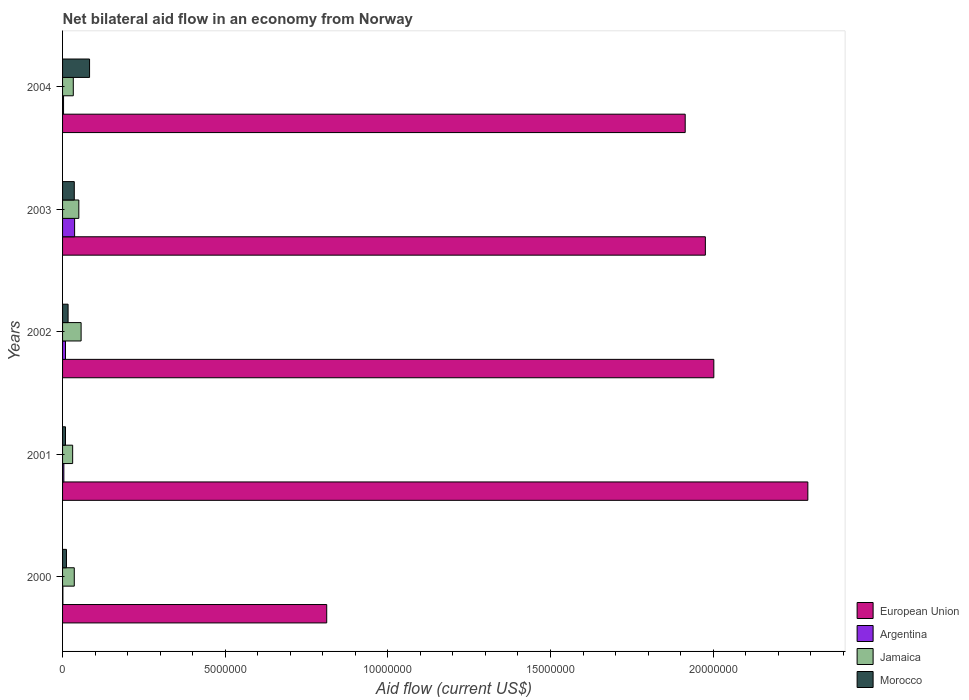How many different coloured bars are there?
Provide a succinct answer. 4. How many bars are there on the 4th tick from the top?
Provide a short and direct response. 4. What is the label of the 2nd group of bars from the top?
Provide a succinct answer. 2003. In how many cases, is the number of bars for a given year not equal to the number of legend labels?
Offer a very short reply. 0. Across all years, what is the maximum net bilateral aid flow in Argentina?
Offer a very short reply. 3.70e+05. Across all years, what is the minimum net bilateral aid flow in Jamaica?
Your response must be concise. 3.10e+05. In which year was the net bilateral aid flow in Jamaica minimum?
Offer a terse response. 2001. What is the total net bilateral aid flow in Jamaica in the graph?
Provide a short and direct response. 2.07e+06. What is the difference between the net bilateral aid flow in Morocco in 2003 and that in 2004?
Offer a terse response. -4.70e+05. What is the difference between the net bilateral aid flow in European Union in 2004 and the net bilateral aid flow in Argentina in 2001?
Offer a very short reply. 1.91e+07. What is the average net bilateral aid flow in Morocco per year?
Provide a short and direct response. 3.14e+05. In the year 2002, what is the difference between the net bilateral aid flow in Morocco and net bilateral aid flow in Jamaica?
Your answer should be compact. -4.00e+05. In how many years, is the net bilateral aid flow in European Union greater than 8000000 US$?
Ensure brevity in your answer.  5. What is the ratio of the net bilateral aid flow in Morocco in 2000 to that in 2001?
Your answer should be very brief. 1.33. Is the net bilateral aid flow in Jamaica in 2000 less than that in 2003?
Your response must be concise. Yes. Is the difference between the net bilateral aid flow in Morocco in 2003 and 2004 greater than the difference between the net bilateral aid flow in Jamaica in 2003 and 2004?
Your answer should be very brief. No. What is the difference between the highest and the second highest net bilateral aid flow in Morocco?
Provide a short and direct response. 4.70e+05. What is the difference between the highest and the lowest net bilateral aid flow in European Union?
Your response must be concise. 1.48e+07. Is it the case that in every year, the sum of the net bilateral aid flow in Argentina and net bilateral aid flow in European Union is greater than the sum of net bilateral aid flow in Jamaica and net bilateral aid flow in Morocco?
Keep it short and to the point. Yes. What does the 4th bar from the top in 2001 represents?
Your response must be concise. European Union. What does the 1st bar from the bottom in 2001 represents?
Provide a succinct answer. European Union. Is it the case that in every year, the sum of the net bilateral aid flow in European Union and net bilateral aid flow in Jamaica is greater than the net bilateral aid flow in Morocco?
Offer a very short reply. Yes. Are all the bars in the graph horizontal?
Your response must be concise. Yes. What is the difference between two consecutive major ticks on the X-axis?
Your answer should be very brief. 5.00e+06. Are the values on the major ticks of X-axis written in scientific E-notation?
Offer a very short reply. No. Does the graph contain grids?
Offer a terse response. No. How many legend labels are there?
Your answer should be very brief. 4. What is the title of the graph?
Ensure brevity in your answer.  Net bilateral aid flow in an economy from Norway. Does "Hong Kong" appear as one of the legend labels in the graph?
Offer a very short reply. No. What is the label or title of the X-axis?
Ensure brevity in your answer.  Aid flow (current US$). What is the label or title of the Y-axis?
Your response must be concise. Years. What is the Aid flow (current US$) in European Union in 2000?
Offer a terse response. 8.12e+06. What is the Aid flow (current US$) of Argentina in 2000?
Keep it short and to the point. 10000. What is the Aid flow (current US$) in Jamaica in 2000?
Offer a terse response. 3.60e+05. What is the Aid flow (current US$) of European Union in 2001?
Offer a very short reply. 2.29e+07. What is the Aid flow (current US$) in Argentina in 2001?
Provide a short and direct response. 4.00e+04. What is the Aid flow (current US$) in Morocco in 2001?
Your answer should be compact. 9.00e+04. What is the Aid flow (current US$) of European Union in 2002?
Your answer should be very brief. 2.00e+07. What is the Aid flow (current US$) of Argentina in 2002?
Offer a terse response. 9.00e+04. What is the Aid flow (current US$) of Jamaica in 2002?
Offer a very short reply. 5.70e+05. What is the Aid flow (current US$) in European Union in 2003?
Ensure brevity in your answer.  1.98e+07. What is the Aid flow (current US$) of Jamaica in 2003?
Keep it short and to the point. 5.00e+05. What is the Aid flow (current US$) in Morocco in 2003?
Your answer should be very brief. 3.60e+05. What is the Aid flow (current US$) in European Union in 2004?
Your answer should be very brief. 1.91e+07. What is the Aid flow (current US$) of Jamaica in 2004?
Provide a succinct answer. 3.30e+05. What is the Aid flow (current US$) in Morocco in 2004?
Provide a succinct answer. 8.30e+05. Across all years, what is the maximum Aid flow (current US$) in European Union?
Your answer should be compact. 2.29e+07. Across all years, what is the maximum Aid flow (current US$) in Argentina?
Make the answer very short. 3.70e+05. Across all years, what is the maximum Aid flow (current US$) of Jamaica?
Keep it short and to the point. 5.70e+05. Across all years, what is the maximum Aid flow (current US$) in Morocco?
Ensure brevity in your answer.  8.30e+05. Across all years, what is the minimum Aid flow (current US$) in European Union?
Your answer should be compact. 8.12e+06. Across all years, what is the minimum Aid flow (current US$) in Jamaica?
Your response must be concise. 3.10e+05. What is the total Aid flow (current US$) of European Union in the graph?
Your response must be concise. 9.00e+07. What is the total Aid flow (current US$) in Argentina in the graph?
Your response must be concise. 5.40e+05. What is the total Aid flow (current US$) of Jamaica in the graph?
Your answer should be very brief. 2.07e+06. What is the total Aid flow (current US$) of Morocco in the graph?
Give a very brief answer. 1.57e+06. What is the difference between the Aid flow (current US$) in European Union in 2000 and that in 2001?
Offer a terse response. -1.48e+07. What is the difference between the Aid flow (current US$) of Argentina in 2000 and that in 2001?
Offer a terse response. -3.00e+04. What is the difference between the Aid flow (current US$) of Jamaica in 2000 and that in 2001?
Offer a very short reply. 5.00e+04. What is the difference between the Aid flow (current US$) of European Union in 2000 and that in 2002?
Keep it short and to the point. -1.19e+07. What is the difference between the Aid flow (current US$) in Argentina in 2000 and that in 2002?
Your answer should be compact. -8.00e+04. What is the difference between the Aid flow (current US$) in Jamaica in 2000 and that in 2002?
Offer a terse response. -2.10e+05. What is the difference between the Aid flow (current US$) in Morocco in 2000 and that in 2002?
Provide a succinct answer. -5.00e+04. What is the difference between the Aid flow (current US$) of European Union in 2000 and that in 2003?
Your answer should be compact. -1.16e+07. What is the difference between the Aid flow (current US$) of Argentina in 2000 and that in 2003?
Offer a terse response. -3.60e+05. What is the difference between the Aid flow (current US$) in Morocco in 2000 and that in 2003?
Your response must be concise. -2.40e+05. What is the difference between the Aid flow (current US$) of European Union in 2000 and that in 2004?
Make the answer very short. -1.10e+07. What is the difference between the Aid flow (current US$) in Argentina in 2000 and that in 2004?
Your answer should be very brief. -2.00e+04. What is the difference between the Aid flow (current US$) in Morocco in 2000 and that in 2004?
Your response must be concise. -7.10e+05. What is the difference between the Aid flow (current US$) of European Union in 2001 and that in 2002?
Your answer should be compact. 2.89e+06. What is the difference between the Aid flow (current US$) in Argentina in 2001 and that in 2002?
Ensure brevity in your answer.  -5.00e+04. What is the difference between the Aid flow (current US$) of Jamaica in 2001 and that in 2002?
Provide a succinct answer. -2.60e+05. What is the difference between the Aid flow (current US$) in European Union in 2001 and that in 2003?
Keep it short and to the point. 3.15e+06. What is the difference between the Aid flow (current US$) in Argentina in 2001 and that in 2003?
Your answer should be compact. -3.30e+05. What is the difference between the Aid flow (current US$) of European Union in 2001 and that in 2004?
Make the answer very short. 3.77e+06. What is the difference between the Aid flow (current US$) in Morocco in 2001 and that in 2004?
Give a very brief answer. -7.40e+05. What is the difference between the Aid flow (current US$) of European Union in 2002 and that in 2003?
Provide a short and direct response. 2.60e+05. What is the difference between the Aid flow (current US$) in Argentina in 2002 and that in 2003?
Provide a succinct answer. -2.80e+05. What is the difference between the Aid flow (current US$) of Morocco in 2002 and that in 2003?
Your answer should be compact. -1.90e+05. What is the difference between the Aid flow (current US$) in European Union in 2002 and that in 2004?
Offer a very short reply. 8.80e+05. What is the difference between the Aid flow (current US$) of Argentina in 2002 and that in 2004?
Ensure brevity in your answer.  6.00e+04. What is the difference between the Aid flow (current US$) of Jamaica in 2002 and that in 2004?
Keep it short and to the point. 2.40e+05. What is the difference between the Aid flow (current US$) of Morocco in 2002 and that in 2004?
Give a very brief answer. -6.60e+05. What is the difference between the Aid flow (current US$) of European Union in 2003 and that in 2004?
Give a very brief answer. 6.20e+05. What is the difference between the Aid flow (current US$) in Jamaica in 2003 and that in 2004?
Make the answer very short. 1.70e+05. What is the difference between the Aid flow (current US$) in Morocco in 2003 and that in 2004?
Your answer should be compact. -4.70e+05. What is the difference between the Aid flow (current US$) of European Union in 2000 and the Aid flow (current US$) of Argentina in 2001?
Provide a succinct answer. 8.08e+06. What is the difference between the Aid flow (current US$) in European Union in 2000 and the Aid flow (current US$) in Jamaica in 2001?
Your response must be concise. 7.81e+06. What is the difference between the Aid flow (current US$) of European Union in 2000 and the Aid flow (current US$) of Morocco in 2001?
Keep it short and to the point. 8.03e+06. What is the difference between the Aid flow (current US$) in Jamaica in 2000 and the Aid flow (current US$) in Morocco in 2001?
Your answer should be compact. 2.70e+05. What is the difference between the Aid flow (current US$) of European Union in 2000 and the Aid flow (current US$) of Argentina in 2002?
Offer a very short reply. 8.03e+06. What is the difference between the Aid flow (current US$) in European Union in 2000 and the Aid flow (current US$) in Jamaica in 2002?
Give a very brief answer. 7.55e+06. What is the difference between the Aid flow (current US$) of European Union in 2000 and the Aid flow (current US$) of Morocco in 2002?
Ensure brevity in your answer.  7.95e+06. What is the difference between the Aid flow (current US$) of Argentina in 2000 and the Aid flow (current US$) of Jamaica in 2002?
Provide a succinct answer. -5.60e+05. What is the difference between the Aid flow (current US$) of Argentina in 2000 and the Aid flow (current US$) of Morocco in 2002?
Ensure brevity in your answer.  -1.60e+05. What is the difference between the Aid flow (current US$) of European Union in 2000 and the Aid flow (current US$) of Argentina in 2003?
Give a very brief answer. 7.75e+06. What is the difference between the Aid flow (current US$) in European Union in 2000 and the Aid flow (current US$) in Jamaica in 2003?
Offer a very short reply. 7.62e+06. What is the difference between the Aid flow (current US$) of European Union in 2000 and the Aid flow (current US$) of Morocco in 2003?
Make the answer very short. 7.76e+06. What is the difference between the Aid flow (current US$) of Argentina in 2000 and the Aid flow (current US$) of Jamaica in 2003?
Offer a very short reply. -4.90e+05. What is the difference between the Aid flow (current US$) in Argentina in 2000 and the Aid flow (current US$) in Morocco in 2003?
Ensure brevity in your answer.  -3.50e+05. What is the difference between the Aid flow (current US$) of European Union in 2000 and the Aid flow (current US$) of Argentina in 2004?
Provide a succinct answer. 8.09e+06. What is the difference between the Aid flow (current US$) in European Union in 2000 and the Aid flow (current US$) in Jamaica in 2004?
Offer a terse response. 7.79e+06. What is the difference between the Aid flow (current US$) in European Union in 2000 and the Aid flow (current US$) in Morocco in 2004?
Offer a terse response. 7.29e+06. What is the difference between the Aid flow (current US$) of Argentina in 2000 and the Aid flow (current US$) of Jamaica in 2004?
Provide a short and direct response. -3.20e+05. What is the difference between the Aid flow (current US$) in Argentina in 2000 and the Aid flow (current US$) in Morocco in 2004?
Your response must be concise. -8.20e+05. What is the difference between the Aid flow (current US$) in Jamaica in 2000 and the Aid flow (current US$) in Morocco in 2004?
Make the answer very short. -4.70e+05. What is the difference between the Aid flow (current US$) of European Union in 2001 and the Aid flow (current US$) of Argentina in 2002?
Give a very brief answer. 2.28e+07. What is the difference between the Aid flow (current US$) of European Union in 2001 and the Aid flow (current US$) of Jamaica in 2002?
Give a very brief answer. 2.23e+07. What is the difference between the Aid flow (current US$) in European Union in 2001 and the Aid flow (current US$) in Morocco in 2002?
Ensure brevity in your answer.  2.27e+07. What is the difference between the Aid flow (current US$) in Argentina in 2001 and the Aid flow (current US$) in Jamaica in 2002?
Your answer should be very brief. -5.30e+05. What is the difference between the Aid flow (current US$) of European Union in 2001 and the Aid flow (current US$) of Argentina in 2003?
Give a very brief answer. 2.25e+07. What is the difference between the Aid flow (current US$) in European Union in 2001 and the Aid flow (current US$) in Jamaica in 2003?
Give a very brief answer. 2.24e+07. What is the difference between the Aid flow (current US$) of European Union in 2001 and the Aid flow (current US$) of Morocco in 2003?
Give a very brief answer. 2.26e+07. What is the difference between the Aid flow (current US$) in Argentina in 2001 and the Aid flow (current US$) in Jamaica in 2003?
Give a very brief answer. -4.60e+05. What is the difference between the Aid flow (current US$) in Argentina in 2001 and the Aid flow (current US$) in Morocco in 2003?
Ensure brevity in your answer.  -3.20e+05. What is the difference between the Aid flow (current US$) of Jamaica in 2001 and the Aid flow (current US$) of Morocco in 2003?
Keep it short and to the point. -5.00e+04. What is the difference between the Aid flow (current US$) of European Union in 2001 and the Aid flow (current US$) of Argentina in 2004?
Your answer should be very brief. 2.29e+07. What is the difference between the Aid flow (current US$) of European Union in 2001 and the Aid flow (current US$) of Jamaica in 2004?
Ensure brevity in your answer.  2.26e+07. What is the difference between the Aid flow (current US$) in European Union in 2001 and the Aid flow (current US$) in Morocco in 2004?
Keep it short and to the point. 2.21e+07. What is the difference between the Aid flow (current US$) in Argentina in 2001 and the Aid flow (current US$) in Morocco in 2004?
Make the answer very short. -7.90e+05. What is the difference between the Aid flow (current US$) of Jamaica in 2001 and the Aid flow (current US$) of Morocco in 2004?
Your answer should be compact. -5.20e+05. What is the difference between the Aid flow (current US$) in European Union in 2002 and the Aid flow (current US$) in Argentina in 2003?
Make the answer very short. 1.96e+07. What is the difference between the Aid flow (current US$) in European Union in 2002 and the Aid flow (current US$) in Jamaica in 2003?
Provide a short and direct response. 1.95e+07. What is the difference between the Aid flow (current US$) of European Union in 2002 and the Aid flow (current US$) of Morocco in 2003?
Your answer should be compact. 1.97e+07. What is the difference between the Aid flow (current US$) in Argentina in 2002 and the Aid flow (current US$) in Jamaica in 2003?
Your answer should be very brief. -4.10e+05. What is the difference between the Aid flow (current US$) in European Union in 2002 and the Aid flow (current US$) in Argentina in 2004?
Make the answer very short. 2.00e+07. What is the difference between the Aid flow (current US$) of European Union in 2002 and the Aid flow (current US$) of Jamaica in 2004?
Give a very brief answer. 1.97e+07. What is the difference between the Aid flow (current US$) in European Union in 2002 and the Aid flow (current US$) in Morocco in 2004?
Offer a terse response. 1.92e+07. What is the difference between the Aid flow (current US$) of Argentina in 2002 and the Aid flow (current US$) of Jamaica in 2004?
Your answer should be compact. -2.40e+05. What is the difference between the Aid flow (current US$) of Argentina in 2002 and the Aid flow (current US$) of Morocco in 2004?
Provide a short and direct response. -7.40e+05. What is the difference between the Aid flow (current US$) of European Union in 2003 and the Aid flow (current US$) of Argentina in 2004?
Provide a short and direct response. 1.97e+07. What is the difference between the Aid flow (current US$) in European Union in 2003 and the Aid flow (current US$) in Jamaica in 2004?
Make the answer very short. 1.94e+07. What is the difference between the Aid flow (current US$) of European Union in 2003 and the Aid flow (current US$) of Morocco in 2004?
Offer a terse response. 1.89e+07. What is the difference between the Aid flow (current US$) in Argentina in 2003 and the Aid flow (current US$) in Morocco in 2004?
Offer a very short reply. -4.60e+05. What is the difference between the Aid flow (current US$) of Jamaica in 2003 and the Aid flow (current US$) of Morocco in 2004?
Your answer should be compact. -3.30e+05. What is the average Aid flow (current US$) of European Union per year?
Ensure brevity in your answer.  1.80e+07. What is the average Aid flow (current US$) in Argentina per year?
Provide a short and direct response. 1.08e+05. What is the average Aid flow (current US$) in Jamaica per year?
Your answer should be compact. 4.14e+05. What is the average Aid flow (current US$) in Morocco per year?
Your response must be concise. 3.14e+05. In the year 2000, what is the difference between the Aid flow (current US$) in European Union and Aid flow (current US$) in Argentina?
Provide a succinct answer. 8.11e+06. In the year 2000, what is the difference between the Aid flow (current US$) in European Union and Aid flow (current US$) in Jamaica?
Your answer should be very brief. 7.76e+06. In the year 2000, what is the difference between the Aid flow (current US$) of European Union and Aid flow (current US$) of Morocco?
Keep it short and to the point. 8.00e+06. In the year 2000, what is the difference between the Aid flow (current US$) of Argentina and Aid flow (current US$) of Jamaica?
Offer a very short reply. -3.50e+05. In the year 2000, what is the difference between the Aid flow (current US$) in Argentina and Aid flow (current US$) in Morocco?
Offer a terse response. -1.10e+05. In the year 2001, what is the difference between the Aid flow (current US$) of European Union and Aid flow (current US$) of Argentina?
Your answer should be compact. 2.29e+07. In the year 2001, what is the difference between the Aid flow (current US$) of European Union and Aid flow (current US$) of Jamaica?
Ensure brevity in your answer.  2.26e+07. In the year 2001, what is the difference between the Aid flow (current US$) in European Union and Aid flow (current US$) in Morocco?
Give a very brief answer. 2.28e+07. In the year 2001, what is the difference between the Aid flow (current US$) of Argentina and Aid flow (current US$) of Morocco?
Offer a very short reply. -5.00e+04. In the year 2002, what is the difference between the Aid flow (current US$) of European Union and Aid flow (current US$) of Argentina?
Offer a terse response. 1.99e+07. In the year 2002, what is the difference between the Aid flow (current US$) in European Union and Aid flow (current US$) in Jamaica?
Offer a terse response. 1.94e+07. In the year 2002, what is the difference between the Aid flow (current US$) of European Union and Aid flow (current US$) of Morocco?
Offer a terse response. 1.98e+07. In the year 2002, what is the difference between the Aid flow (current US$) of Argentina and Aid flow (current US$) of Jamaica?
Offer a terse response. -4.80e+05. In the year 2002, what is the difference between the Aid flow (current US$) of Argentina and Aid flow (current US$) of Morocco?
Offer a terse response. -8.00e+04. In the year 2002, what is the difference between the Aid flow (current US$) of Jamaica and Aid flow (current US$) of Morocco?
Offer a terse response. 4.00e+05. In the year 2003, what is the difference between the Aid flow (current US$) of European Union and Aid flow (current US$) of Argentina?
Your answer should be very brief. 1.94e+07. In the year 2003, what is the difference between the Aid flow (current US$) in European Union and Aid flow (current US$) in Jamaica?
Your answer should be compact. 1.93e+07. In the year 2003, what is the difference between the Aid flow (current US$) in European Union and Aid flow (current US$) in Morocco?
Your answer should be compact. 1.94e+07. In the year 2003, what is the difference between the Aid flow (current US$) in Argentina and Aid flow (current US$) in Morocco?
Offer a very short reply. 10000. In the year 2004, what is the difference between the Aid flow (current US$) in European Union and Aid flow (current US$) in Argentina?
Give a very brief answer. 1.91e+07. In the year 2004, what is the difference between the Aid flow (current US$) in European Union and Aid flow (current US$) in Jamaica?
Your response must be concise. 1.88e+07. In the year 2004, what is the difference between the Aid flow (current US$) of European Union and Aid flow (current US$) of Morocco?
Provide a short and direct response. 1.83e+07. In the year 2004, what is the difference between the Aid flow (current US$) of Argentina and Aid flow (current US$) of Morocco?
Provide a succinct answer. -8.00e+05. In the year 2004, what is the difference between the Aid flow (current US$) in Jamaica and Aid flow (current US$) in Morocco?
Provide a short and direct response. -5.00e+05. What is the ratio of the Aid flow (current US$) of European Union in 2000 to that in 2001?
Ensure brevity in your answer.  0.35. What is the ratio of the Aid flow (current US$) in Argentina in 2000 to that in 2001?
Your answer should be very brief. 0.25. What is the ratio of the Aid flow (current US$) in Jamaica in 2000 to that in 2001?
Keep it short and to the point. 1.16. What is the ratio of the Aid flow (current US$) in Morocco in 2000 to that in 2001?
Provide a short and direct response. 1.33. What is the ratio of the Aid flow (current US$) of European Union in 2000 to that in 2002?
Provide a short and direct response. 0.41. What is the ratio of the Aid flow (current US$) of Jamaica in 2000 to that in 2002?
Provide a short and direct response. 0.63. What is the ratio of the Aid flow (current US$) in Morocco in 2000 to that in 2002?
Your answer should be compact. 0.71. What is the ratio of the Aid flow (current US$) of European Union in 2000 to that in 2003?
Offer a very short reply. 0.41. What is the ratio of the Aid flow (current US$) in Argentina in 2000 to that in 2003?
Your answer should be very brief. 0.03. What is the ratio of the Aid flow (current US$) of Jamaica in 2000 to that in 2003?
Your answer should be compact. 0.72. What is the ratio of the Aid flow (current US$) of Morocco in 2000 to that in 2003?
Ensure brevity in your answer.  0.33. What is the ratio of the Aid flow (current US$) in European Union in 2000 to that in 2004?
Your answer should be compact. 0.42. What is the ratio of the Aid flow (current US$) of Jamaica in 2000 to that in 2004?
Give a very brief answer. 1.09. What is the ratio of the Aid flow (current US$) in Morocco in 2000 to that in 2004?
Your answer should be very brief. 0.14. What is the ratio of the Aid flow (current US$) in European Union in 2001 to that in 2002?
Ensure brevity in your answer.  1.14. What is the ratio of the Aid flow (current US$) in Argentina in 2001 to that in 2002?
Your answer should be very brief. 0.44. What is the ratio of the Aid flow (current US$) in Jamaica in 2001 to that in 2002?
Keep it short and to the point. 0.54. What is the ratio of the Aid flow (current US$) in Morocco in 2001 to that in 2002?
Make the answer very short. 0.53. What is the ratio of the Aid flow (current US$) of European Union in 2001 to that in 2003?
Make the answer very short. 1.16. What is the ratio of the Aid flow (current US$) in Argentina in 2001 to that in 2003?
Your response must be concise. 0.11. What is the ratio of the Aid flow (current US$) in Jamaica in 2001 to that in 2003?
Your response must be concise. 0.62. What is the ratio of the Aid flow (current US$) in Morocco in 2001 to that in 2003?
Your answer should be very brief. 0.25. What is the ratio of the Aid flow (current US$) in European Union in 2001 to that in 2004?
Provide a succinct answer. 1.2. What is the ratio of the Aid flow (current US$) of Argentina in 2001 to that in 2004?
Give a very brief answer. 1.33. What is the ratio of the Aid flow (current US$) in Jamaica in 2001 to that in 2004?
Your answer should be compact. 0.94. What is the ratio of the Aid flow (current US$) in Morocco in 2001 to that in 2004?
Give a very brief answer. 0.11. What is the ratio of the Aid flow (current US$) of European Union in 2002 to that in 2003?
Give a very brief answer. 1.01. What is the ratio of the Aid flow (current US$) in Argentina in 2002 to that in 2003?
Your answer should be compact. 0.24. What is the ratio of the Aid flow (current US$) of Jamaica in 2002 to that in 2003?
Provide a short and direct response. 1.14. What is the ratio of the Aid flow (current US$) in Morocco in 2002 to that in 2003?
Make the answer very short. 0.47. What is the ratio of the Aid flow (current US$) in European Union in 2002 to that in 2004?
Keep it short and to the point. 1.05. What is the ratio of the Aid flow (current US$) in Jamaica in 2002 to that in 2004?
Your answer should be very brief. 1.73. What is the ratio of the Aid flow (current US$) of Morocco in 2002 to that in 2004?
Your response must be concise. 0.2. What is the ratio of the Aid flow (current US$) of European Union in 2003 to that in 2004?
Keep it short and to the point. 1.03. What is the ratio of the Aid flow (current US$) in Argentina in 2003 to that in 2004?
Ensure brevity in your answer.  12.33. What is the ratio of the Aid flow (current US$) of Jamaica in 2003 to that in 2004?
Provide a short and direct response. 1.52. What is the ratio of the Aid flow (current US$) in Morocco in 2003 to that in 2004?
Your response must be concise. 0.43. What is the difference between the highest and the second highest Aid flow (current US$) of European Union?
Provide a short and direct response. 2.89e+06. What is the difference between the highest and the lowest Aid flow (current US$) in European Union?
Offer a terse response. 1.48e+07. What is the difference between the highest and the lowest Aid flow (current US$) in Morocco?
Offer a terse response. 7.40e+05. 